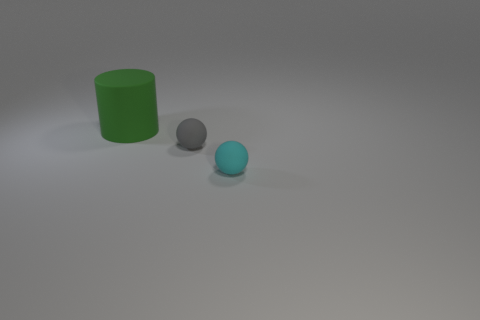Subtract 1 cylinders. How many cylinders are left? 0 Add 2 tiny shiny spheres. How many objects exist? 5 Add 1 small gray matte spheres. How many small gray matte spheres are left? 2 Add 2 green rubber cylinders. How many green rubber cylinders exist? 3 Subtract 0 yellow spheres. How many objects are left? 3 Subtract all cylinders. How many objects are left? 2 Subtract all red cylinders. Subtract all cyan balls. How many cylinders are left? 1 Subtract all cyan blocks. How many red spheres are left? 0 Subtract all small gray spheres. Subtract all small spheres. How many objects are left? 0 